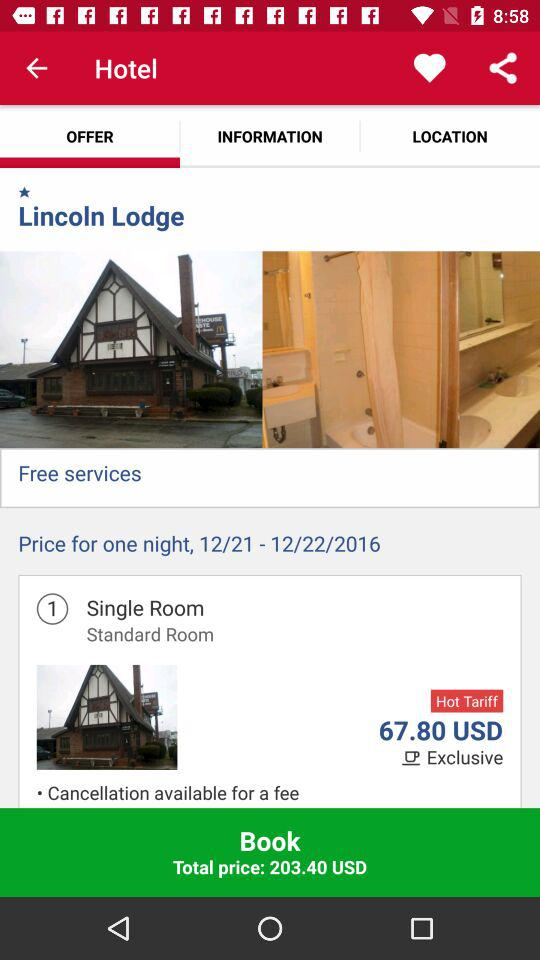How many days is the stay?
Answer the question using a single word or phrase. 1 